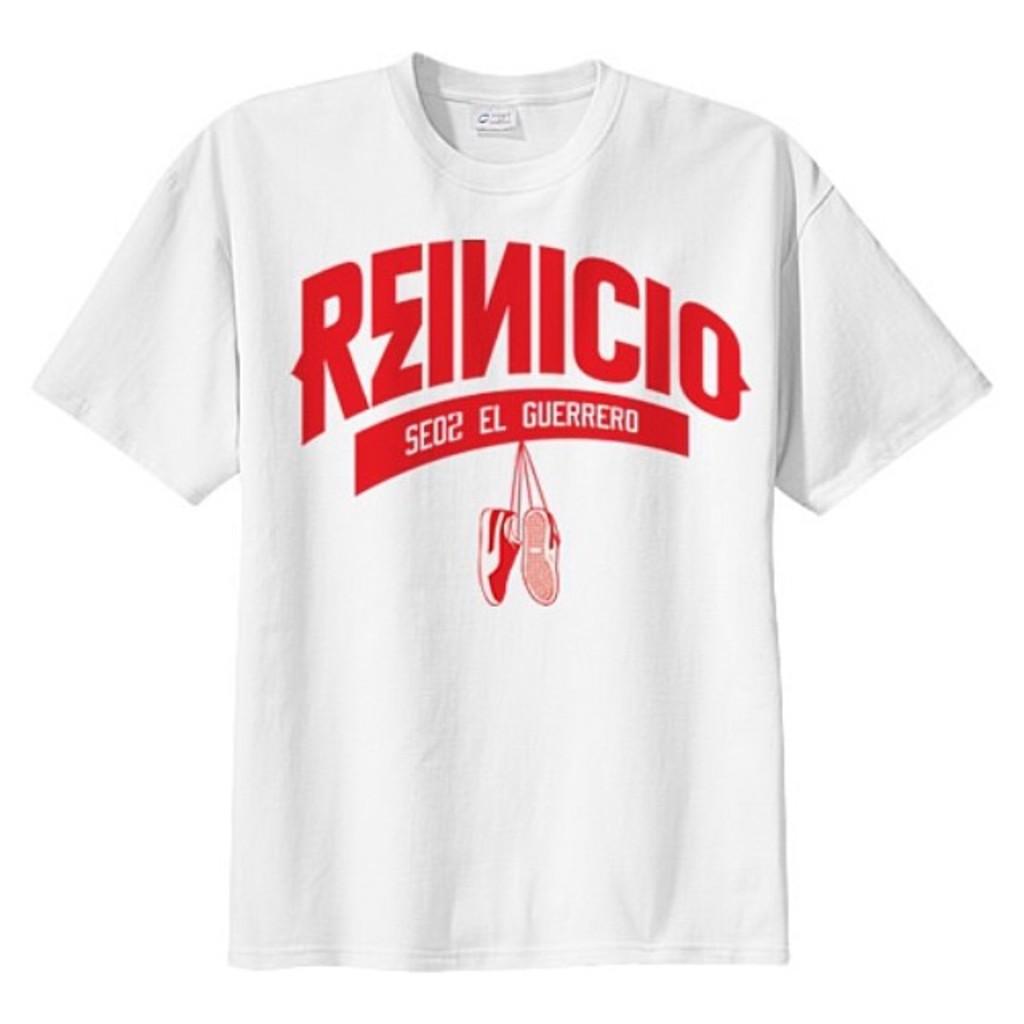What color is the large text on the shirt?
Make the answer very short. Answering does not require reading text in the image. 